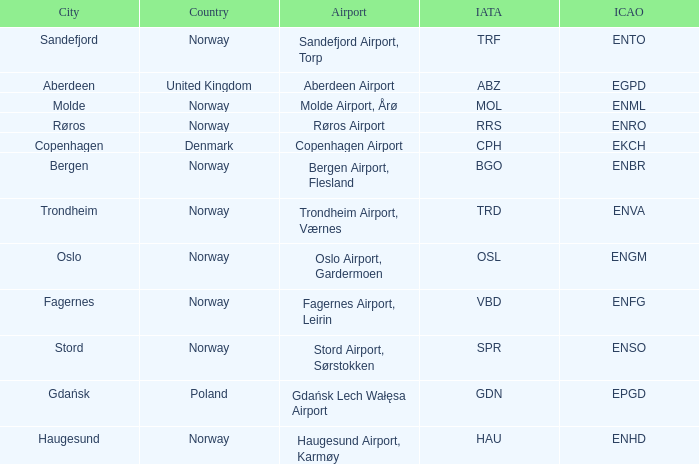In what Country is Haugesund? Norway. 